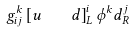<formula> <loc_0><loc_0><loc_500><loc_500>g _ { i j } ^ { k } \left [ u \quad d \right ] _ { L } ^ { i } \phi ^ { k } d _ { R } ^ { j }</formula> 